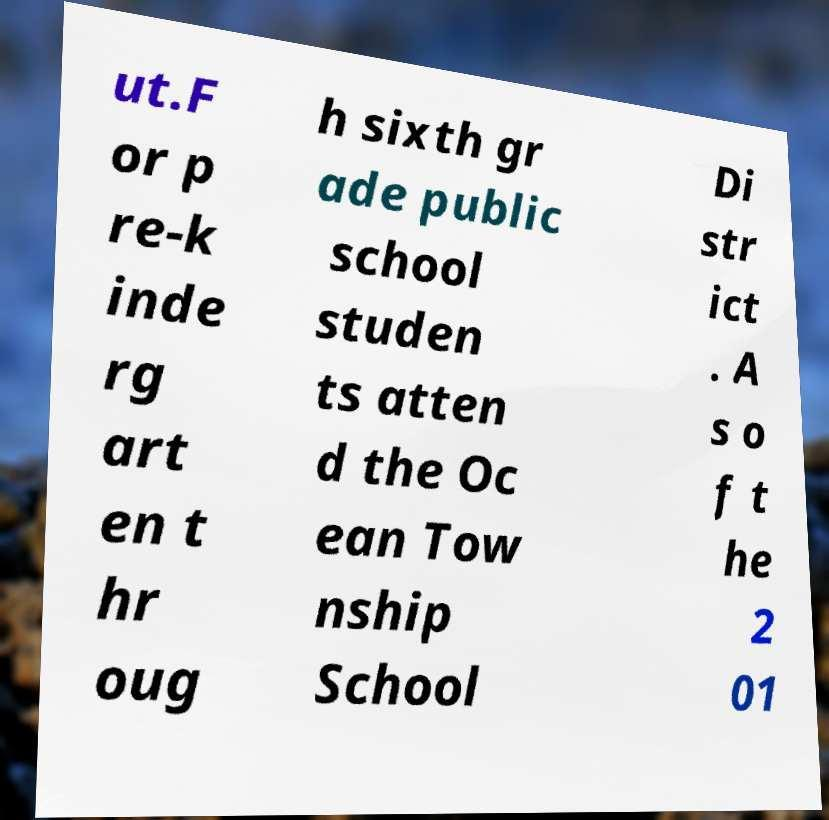Can you accurately transcribe the text from the provided image for me? ut.F or p re-k inde rg art en t hr oug h sixth gr ade public school studen ts atten d the Oc ean Tow nship School Di str ict . A s o f t he 2 01 